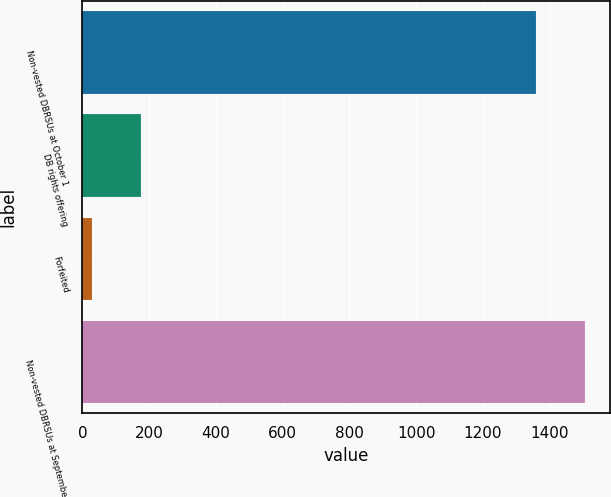<chart> <loc_0><loc_0><loc_500><loc_500><bar_chart><fcel>Non-vested DBRSUs at October 1<fcel>DB rights offering<fcel>Forfeited<fcel>Non-vested DBRSUs at September<nl><fcel>1358<fcel>174.5<fcel>28<fcel>1504.5<nl></chart> 